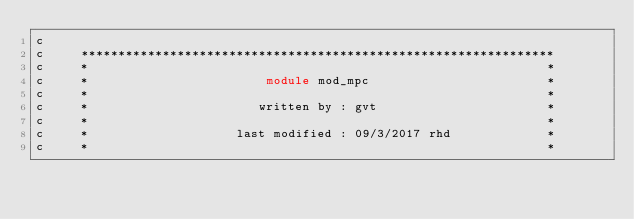<code> <loc_0><loc_0><loc_500><loc_500><_FORTRAN_>c
c     ****************************************************************
c     *                                                              *
c     *                        module mod_mpc                        *
c     *                                                              *
c     *                       written by : gvt                       *
c     *                                                              *
c     *                    last modified : 09/3/2017 rhd             *
c     *                                                              *</code> 